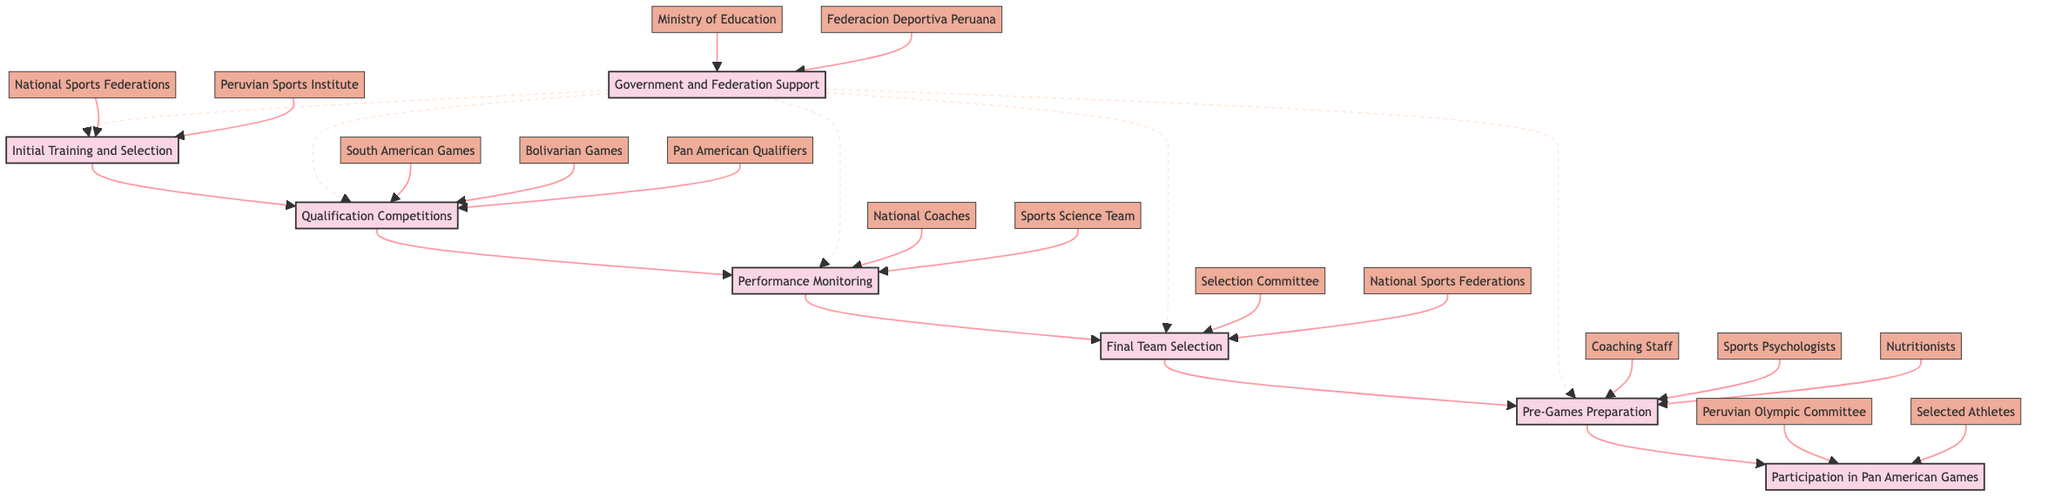What is the first stage in Peru's qualification pathway for the Pan American Games? The diagram indicates that the first stage is "Initial Training and Selection." This is the starting point of the flow chart and is connected to the second stage.
Answer: Initial Training and Selection How many main stages are there in the pathway? Counting the stages listed in the diagram, there are a total of seven main stages from "Initial Training and Selection" to "Participation in Pan American Games."
Answer: 7 Which entities support the "Government and Federation Support" stage? The "Government and Federation Support" stage has two entities listed: "Ministry of Education" and "Federacion Deportiva Peruana." This information can be seen connected to stage C in the diagram.
Answer: Ministry of Education, Federacion Deportiva Peruana What role do "National Coaches" play in the pathway? "National Coaches" are associated with the "Performance Monitoring" stage, indicating their role is related to evaluating athletes' performance during training and competitions. This is depicted in stage D of the flow chart.
Answer: Performance Monitoring What is the last stage before athletes compete in the Pan American Games? The last stage before the competition is "Pre-Games Preparation," which focuses on training and strategizing before the event. It is connected directly to the "Participation in Pan American Games."
Answer: Pre-Games Preparation How does "Government and Federation Support" interact with "Qualification Competitions"? The diagram shows that "Government and Federation Support" has a dotted line connecting to "Qualification Competitions," indicating that support is provided but not in a direct manner as with the solid connections. This shows an indirect relationship between the two stages.
Answer: Indirect support Which stage follows "Final Team Selection"? According to the flow of the diagram, the stage that directly follows "Final Team Selection" is "Pre-Games Preparation." This sequential flow can be easily tracked along the directed arrows in the chart.
Answer: Pre-Games Preparation 